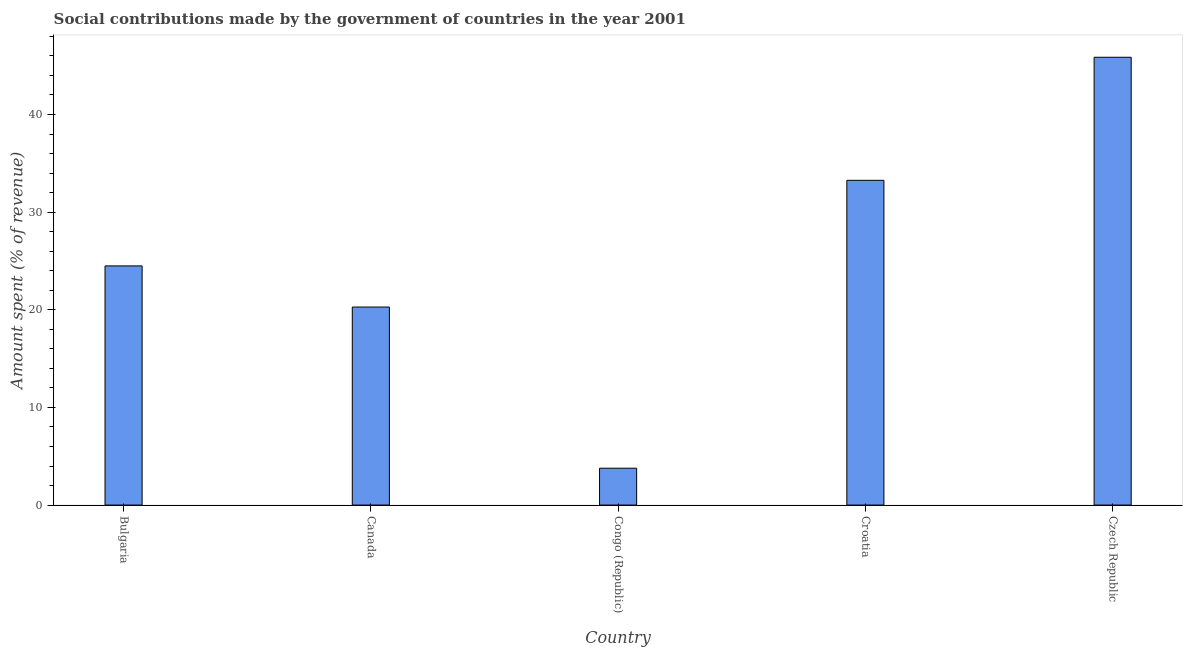Does the graph contain grids?
Offer a terse response. No. What is the title of the graph?
Offer a terse response. Social contributions made by the government of countries in the year 2001. What is the label or title of the X-axis?
Offer a very short reply. Country. What is the label or title of the Y-axis?
Your answer should be compact. Amount spent (% of revenue). What is the amount spent in making social contributions in Croatia?
Offer a terse response. 33.26. Across all countries, what is the maximum amount spent in making social contributions?
Make the answer very short. 45.86. Across all countries, what is the minimum amount spent in making social contributions?
Give a very brief answer. 3.78. In which country was the amount spent in making social contributions maximum?
Your response must be concise. Czech Republic. In which country was the amount spent in making social contributions minimum?
Your answer should be compact. Congo (Republic). What is the sum of the amount spent in making social contributions?
Keep it short and to the point. 127.66. What is the difference between the amount spent in making social contributions in Congo (Republic) and Czech Republic?
Make the answer very short. -42.08. What is the average amount spent in making social contributions per country?
Provide a short and direct response. 25.53. What is the median amount spent in making social contributions?
Make the answer very short. 24.49. In how many countries, is the amount spent in making social contributions greater than 32 %?
Offer a very short reply. 2. What is the ratio of the amount spent in making social contributions in Congo (Republic) to that in Croatia?
Provide a succinct answer. 0.11. Is the amount spent in making social contributions in Congo (Republic) less than that in Croatia?
Give a very brief answer. Yes. What is the difference between the highest and the second highest amount spent in making social contributions?
Your response must be concise. 12.6. What is the difference between the highest and the lowest amount spent in making social contributions?
Provide a short and direct response. 42.08. In how many countries, is the amount spent in making social contributions greater than the average amount spent in making social contributions taken over all countries?
Keep it short and to the point. 2. How many bars are there?
Provide a short and direct response. 5. Are the values on the major ticks of Y-axis written in scientific E-notation?
Provide a short and direct response. No. What is the Amount spent (% of revenue) in Bulgaria?
Your response must be concise. 24.49. What is the Amount spent (% of revenue) in Canada?
Make the answer very short. 20.28. What is the Amount spent (% of revenue) in Congo (Republic)?
Make the answer very short. 3.78. What is the Amount spent (% of revenue) of Croatia?
Give a very brief answer. 33.26. What is the Amount spent (% of revenue) in Czech Republic?
Ensure brevity in your answer.  45.86. What is the difference between the Amount spent (% of revenue) in Bulgaria and Canada?
Give a very brief answer. 4.21. What is the difference between the Amount spent (% of revenue) in Bulgaria and Congo (Republic)?
Your response must be concise. 20.72. What is the difference between the Amount spent (% of revenue) in Bulgaria and Croatia?
Provide a short and direct response. -8.77. What is the difference between the Amount spent (% of revenue) in Bulgaria and Czech Republic?
Provide a short and direct response. -21.37. What is the difference between the Amount spent (% of revenue) in Canada and Congo (Republic)?
Provide a short and direct response. 16.5. What is the difference between the Amount spent (% of revenue) in Canada and Croatia?
Provide a succinct answer. -12.98. What is the difference between the Amount spent (% of revenue) in Canada and Czech Republic?
Your answer should be very brief. -25.58. What is the difference between the Amount spent (% of revenue) in Congo (Republic) and Croatia?
Your answer should be compact. -29.48. What is the difference between the Amount spent (% of revenue) in Congo (Republic) and Czech Republic?
Offer a very short reply. -42.08. What is the difference between the Amount spent (% of revenue) in Croatia and Czech Republic?
Provide a succinct answer. -12.6. What is the ratio of the Amount spent (% of revenue) in Bulgaria to that in Canada?
Your answer should be compact. 1.21. What is the ratio of the Amount spent (% of revenue) in Bulgaria to that in Congo (Republic)?
Your response must be concise. 6.49. What is the ratio of the Amount spent (% of revenue) in Bulgaria to that in Croatia?
Your answer should be compact. 0.74. What is the ratio of the Amount spent (% of revenue) in Bulgaria to that in Czech Republic?
Your answer should be compact. 0.53. What is the ratio of the Amount spent (% of revenue) in Canada to that in Congo (Republic)?
Give a very brief answer. 5.37. What is the ratio of the Amount spent (% of revenue) in Canada to that in Croatia?
Provide a short and direct response. 0.61. What is the ratio of the Amount spent (% of revenue) in Canada to that in Czech Republic?
Your answer should be compact. 0.44. What is the ratio of the Amount spent (% of revenue) in Congo (Republic) to that in Croatia?
Your response must be concise. 0.11. What is the ratio of the Amount spent (% of revenue) in Congo (Republic) to that in Czech Republic?
Ensure brevity in your answer.  0.08. What is the ratio of the Amount spent (% of revenue) in Croatia to that in Czech Republic?
Provide a short and direct response. 0.72. 